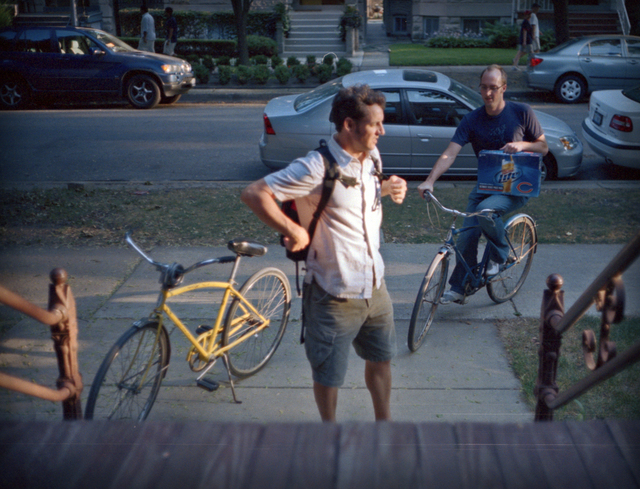What is the object in the image? The object in the image is a vibrant yellow bicycle positioned in the center, standing upright which likely indicates the presence of a kickstand or it being skillfully balanced. This bicyle features a classic design with high handlebars and a gesture towards comfortable commuting or casual riding. The scene captures a typical, relaxed urban setting, possibly suggesting its frequent use in daily urban commutes or leisurely city rides. 